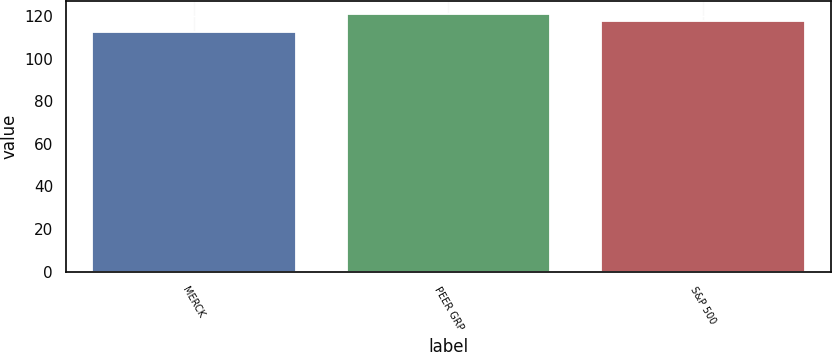Convert chart. <chart><loc_0><loc_0><loc_500><loc_500><bar_chart><fcel>MERCK<fcel>PEER GRP<fcel>S&P 500<nl><fcel>112.67<fcel>121.01<fcel>117.49<nl></chart> 